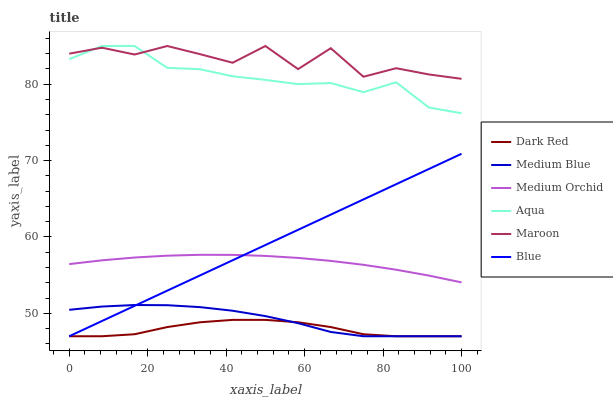Does Dark Red have the minimum area under the curve?
Answer yes or no. Yes. Does Maroon have the maximum area under the curve?
Answer yes or no. Yes. Does Medium Orchid have the minimum area under the curve?
Answer yes or no. No. Does Medium Orchid have the maximum area under the curve?
Answer yes or no. No. Is Blue the smoothest?
Answer yes or no. Yes. Is Maroon the roughest?
Answer yes or no. Yes. Is Dark Red the smoothest?
Answer yes or no. No. Is Dark Red the roughest?
Answer yes or no. No. Does Blue have the lowest value?
Answer yes or no. Yes. Does Medium Orchid have the lowest value?
Answer yes or no. No. Does Maroon have the highest value?
Answer yes or no. Yes. Does Medium Orchid have the highest value?
Answer yes or no. No. Is Medium Blue less than Medium Orchid?
Answer yes or no. Yes. Is Aqua greater than Dark Red?
Answer yes or no. Yes. Does Aqua intersect Maroon?
Answer yes or no. Yes. Is Aqua less than Maroon?
Answer yes or no. No. Is Aqua greater than Maroon?
Answer yes or no. No. Does Medium Blue intersect Medium Orchid?
Answer yes or no. No. 